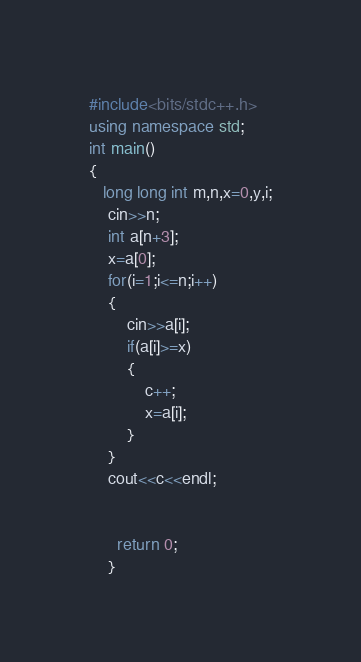Convert code to text. <code><loc_0><loc_0><loc_500><loc_500><_C++_>#include<bits/stdc++.h>
using namespace std;
int main()
{
   long long int m,n,x=0,y,i;
    cin>>n;
    int a[n+3];
    x=a[0];
    for(i=1;i<=n;i++)
    {
        cin>>a[i];
        if(a[i]>=x)
        {
            c++;
            x=a[i];
        }
    }
    cout<<c<<endl;


      return 0;
    }
</code> 